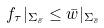Convert formula to latex. <formula><loc_0><loc_0><loc_500><loc_500>f _ { \tau } | _ { \Sigma _ { \bar { s } } } \leq \bar { w } | _ { \Sigma _ { \bar { s } } }</formula> 